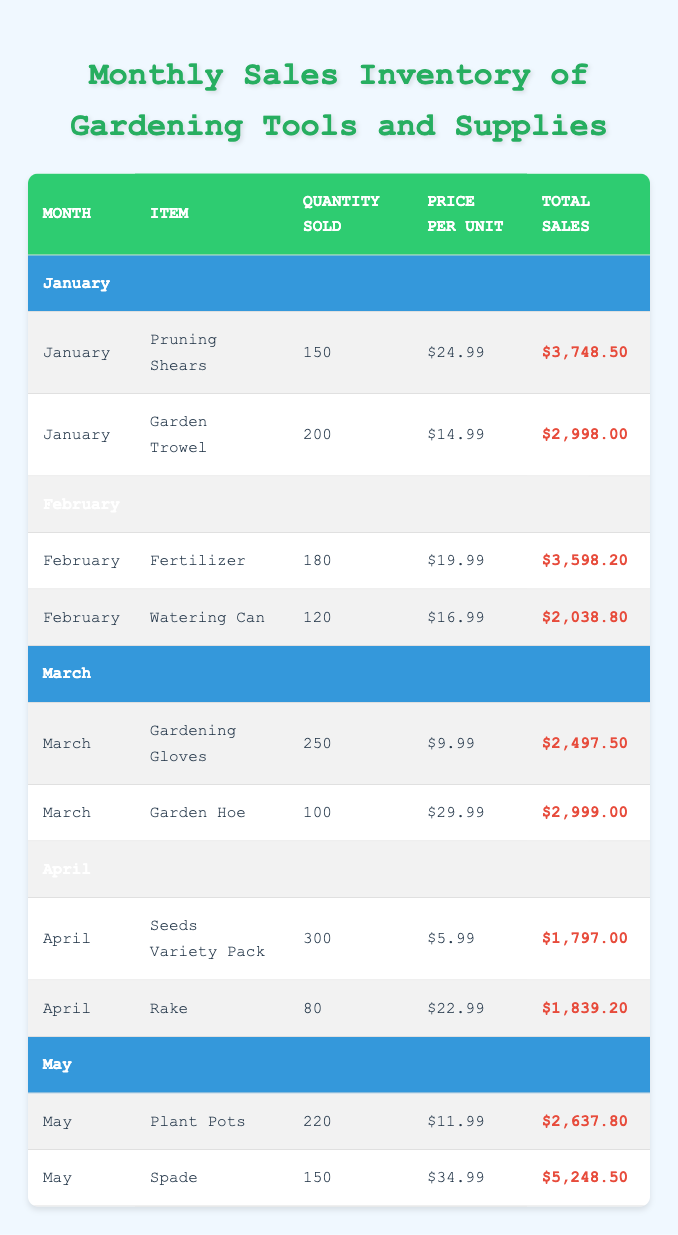What is the total sales amount for Pruning Shears in January? The table states that 150 Pruning Shears were sold in January at a price of $24.99 per unit. To find the total sales, we multiply the quantity sold (150) by the price per unit (24.99), which equals 3748.50.
Answer: 3748.50 How many Garden Trowels were sold in January? According to the table, the quantity sold for Garden Trowels in January is explicitly listed as 200.
Answer: 200 Which item had the highest total sales in May? In May, the total sales are given as follows: Plant Pots: 2637.80 and Spade: 5248.50. Comparing these two amounts, the Spade has the higher total sales of 5248.50.
Answer: Spade What was the average price per unit for all items sold in January? In January, the items sold were Pruning Shears ($24.99) and Garden Trowels ($14.99). To find the average, we calculate (24.99 + 14.99) / 2, which equals 19.99.
Answer: 19.99 Were more Gardening Gloves sold in March than Watering Cans in February? In March, 250 Gardening Gloves were sold, while in February, 120 Watering Cans were sold. Since 250 is greater than 120, the statement is true.
Answer: Yes What is the total quantity of Gardening Tools sold during the months of January to April combined? The quantities sold in each month are: January: 150 (Pruning Shears) + 200 (Garden Trowel) = 350, February: 180 (Fertilizer) + 120 (Watering Can) = 300, March: 250 (Gardening Gloves) + 100 (Garden Hoe) = 350, April: 300 (Seeds Variety Pack) + 80 (Rake) = 380. Adding these values together gives: 350 + 300 + 350 + 380 = 1380.
Answer: 1380 Is the total sales price for Seeds Variety Pack greater than the total sales price for Rakes in April? The total sales for Seeds Variety Pack is 1797.00 and for Rakes, it is 1839.20. Since 1797.00 is less than 1839.20, the statement is false.
Answer: No Calculate the total sales for all items sold in May. In May, the total sales are: Plant Pots: 2637.80 and Spade: 5248.50. To find the total, we add these two figures: 2637.80 + 5248.50 = 7886.30.
Answer: 7886.30 What item was sold in February besides Fertilizer? In February, the items listed are Fertilizer and Watering Can. Therefore, besides Fertilizer, the other item is Watering Can.
Answer: Watering Can 